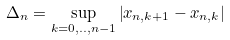<formula> <loc_0><loc_0><loc_500><loc_500>\Delta _ { n } = \sup _ { k = 0 , . . , n - 1 } \left | x _ { n , k + 1 } - x _ { n , k } \right |</formula> 